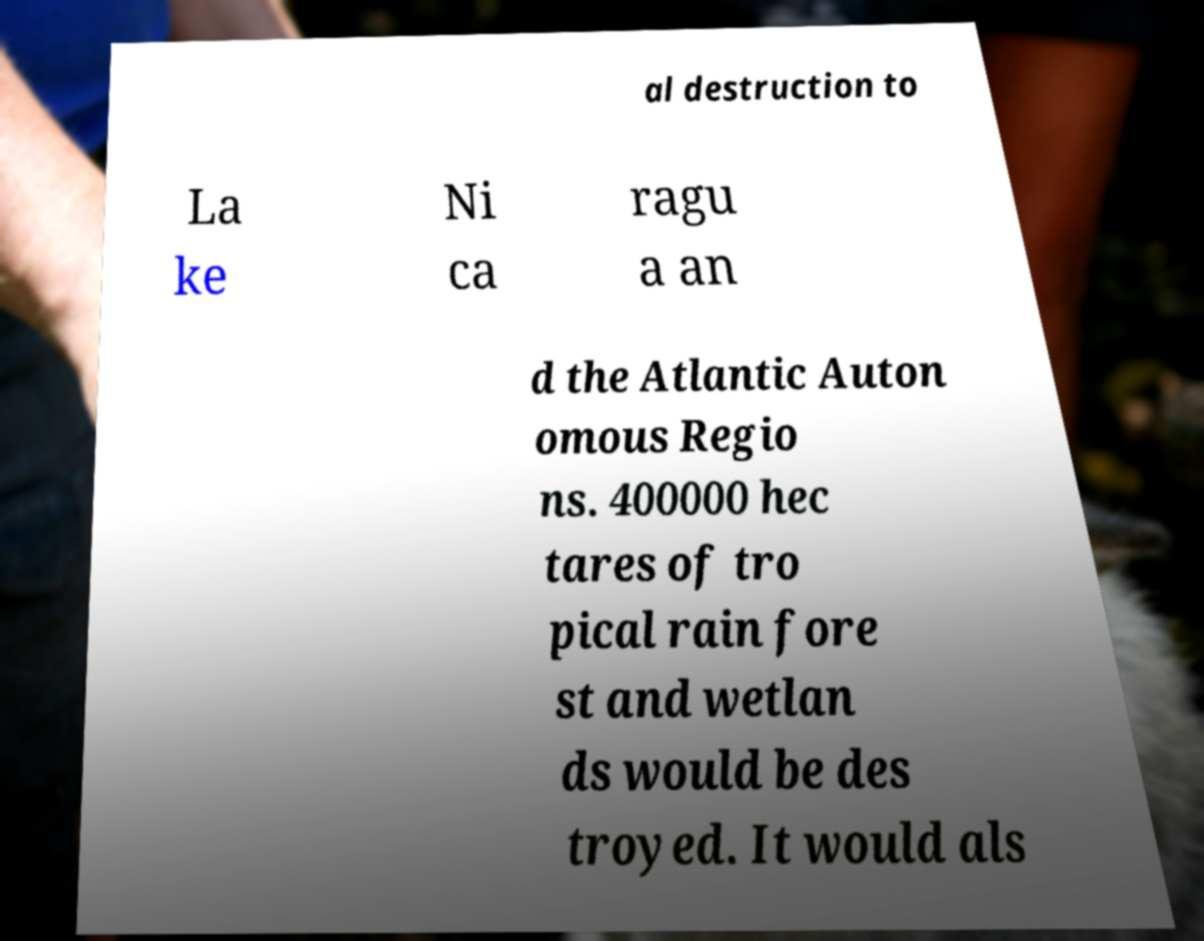I need the written content from this picture converted into text. Can you do that? al destruction to La ke Ni ca ragu a an d the Atlantic Auton omous Regio ns. 400000 hec tares of tro pical rain fore st and wetlan ds would be des troyed. It would als 